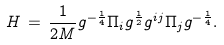Convert formula to latex. <formula><loc_0><loc_0><loc_500><loc_500>H \, = \, \frac { 1 } { 2 M } g ^ { - \frac { 1 } { 4 } } \Pi _ { i } g ^ { \frac { 1 } { 2 } } g ^ { i j } \Pi _ { j } g ^ { - \frac { 1 } { 4 } } .</formula> 